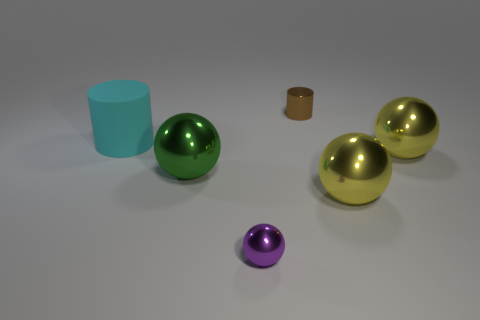What colors are the spheres in the image? In the image, there are spheres in three different colors: one is green, two are gold, and one is purple. 